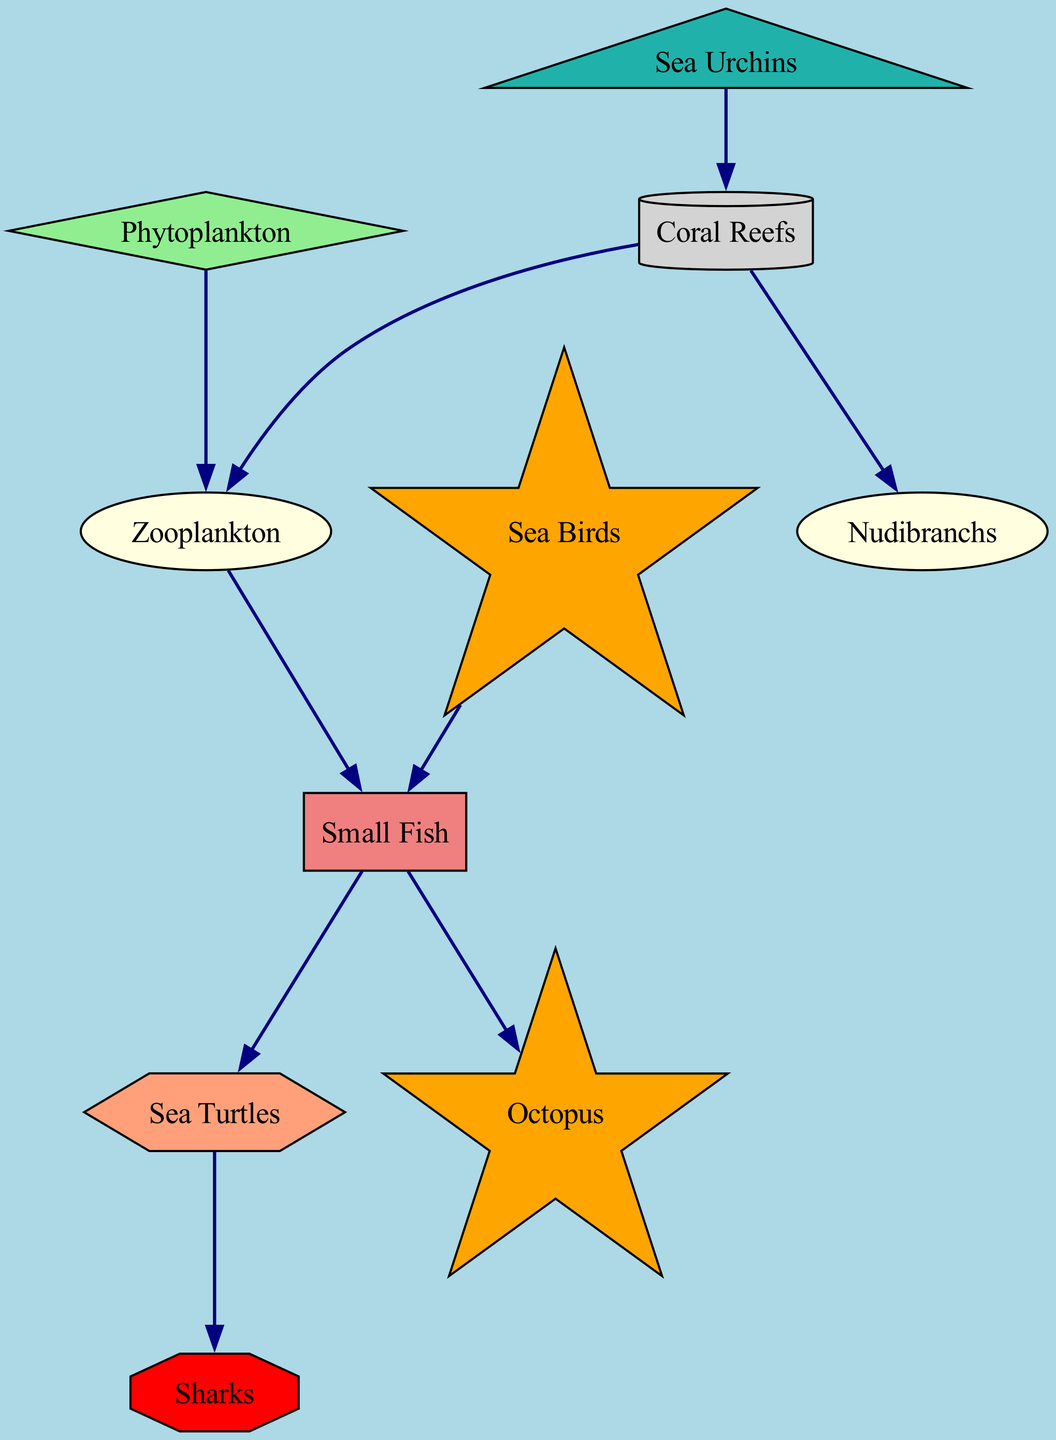What is the total number of nodes in the diagram? The diagram has 10 nodes listed under the "nodes" section, which represent various organisms and habitats.
Answer: 10 Which node is classified as a producer? The "Phytoplankton" node is identified as a producer based on its type designation in the data provided.
Answer: Phytoplankton How many edges connect Sea Turtles and Sharks? There is a single directed edge from "Sea Turtles" to "Sharks," indicating a direct relationship where Sea Turtles are prey for Sharks.
Answer: 1 What type of node is Sea Urchins? Sea Urchins is classified as an herbivore, which is specified in the node type classification in the data.
Answer: herbivore Which organism is the primary consumer that does not feed on Zooplankton? The "Nudibranchs" node is a primary consumer that is connected only to Coral Reefs and does not feed on Zooplankton in the diagram.
Answer: Nudibranchs What is the relationship direction from Coral Reefs to Zooplankton? The edge from "Coral Reefs" to "Zooplankton" flows in the direction where Coral Reefs provide habitat which supports Zooplankton, making it a food source.
Answer: Coral Reefs to Zooplankton How many primary consumers are in the diagram? There are two primary consumers, "Zooplankton" and "Nudibranchs," as classified in the "nodes" section of the diagram.
Answer: 2 Which predator eats Small Fish? The node "Sea Birds" indicates that it preys on Small Fish as shown by the directed edge from Sea Birds to Small Fish.
Answer: Sea Birds Is there a direct connection from a tertiary consumer to a quaternary consumer? Yes, there is a direct edge from "Sea Turtles" (tertiary consumer) to "Sharks" (quaternary consumer), indicating a direct predator-prey relationship.
Answer: Yes 